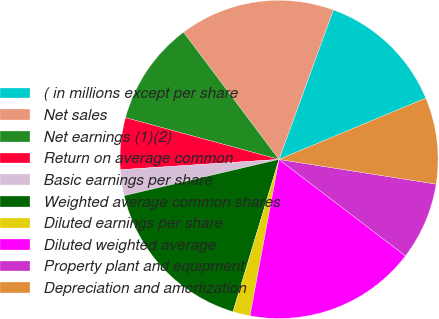Convert chart to OTSL. <chart><loc_0><loc_0><loc_500><loc_500><pie_chart><fcel>( in millions except per share<fcel>Net sales<fcel>Net earnings (1)(2)<fcel>Return on average common<fcel>Basic earnings per share<fcel>Weighted average common shares<fcel>Diluted earnings per share<fcel>Diluted weighted average<fcel>Property plant and equipment<fcel>Depreciation and amortization<nl><fcel>13.16%<fcel>15.79%<fcel>10.53%<fcel>5.26%<fcel>2.63%<fcel>16.67%<fcel>1.75%<fcel>17.54%<fcel>7.89%<fcel>8.77%<nl></chart> 